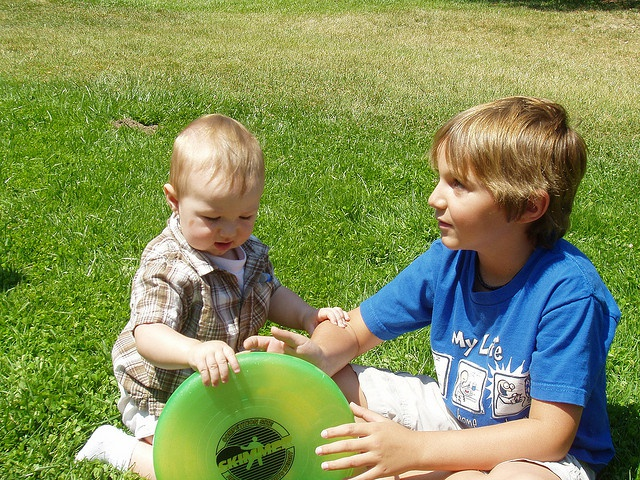Describe the objects in this image and their specific colors. I can see people in olive, ivory, tan, navy, and lightblue tones, people in olive, ivory, gray, and tan tones, and frisbee in olive, green, and lightgreen tones in this image. 